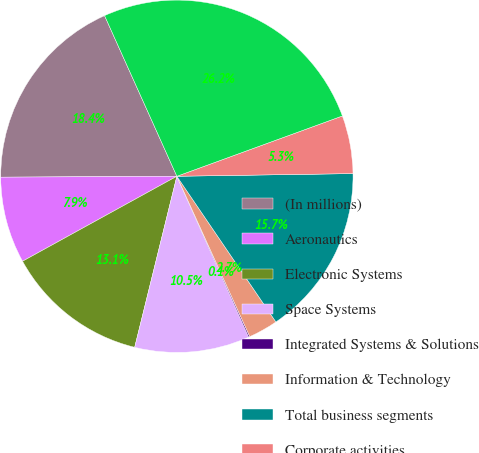<chart> <loc_0><loc_0><loc_500><loc_500><pie_chart><fcel>(In millions)<fcel>Aeronautics<fcel>Electronic Systems<fcel>Space Systems<fcel>Integrated Systems & Solutions<fcel>Information & Technology<fcel>Total business segments<fcel>Corporate activities<fcel>Corporate activities (d)<nl><fcel>18.35%<fcel>7.93%<fcel>13.14%<fcel>10.53%<fcel>0.11%<fcel>2.71%<fcel>15.74%<fcel>5.32%<fcel>26.17%<nl></chart> 